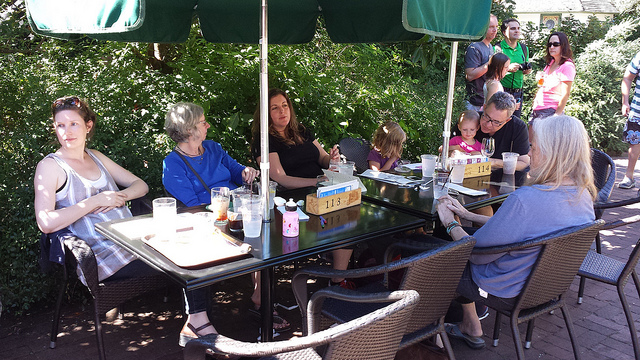Please transcribe the text information in this image. 113 114 